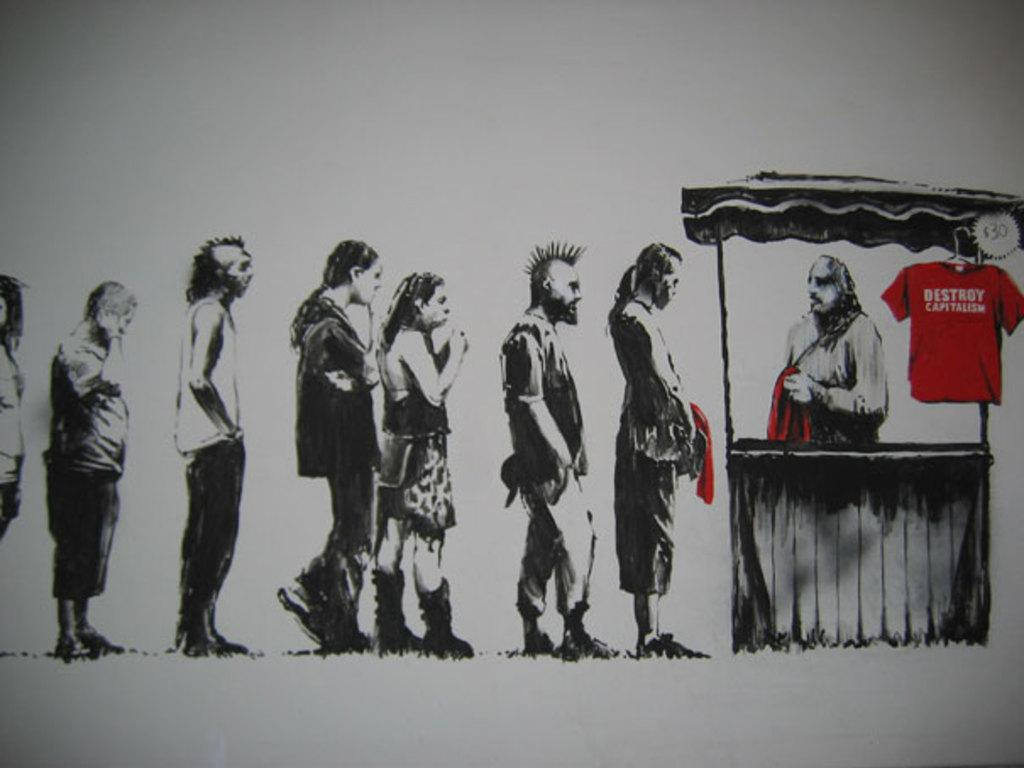What is the main subject of the image? The main subject of the image is a group of people. What are the people in the image doing? The group of people is standing. Can you describe any specific clothing worn by someone in the image? There is a person wearing a red shirt in the image. What color is the background of the image? The background of the image is white. How many snakes can be seen slithering in the image? There are no snakes present in the image. What type of harbor can be seen in the background of the image? There is no harbor visible in the image; the background is white. 